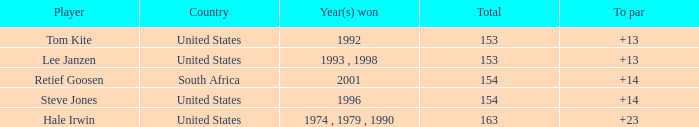What is the total that South Africa had a par greater than 14 None. 